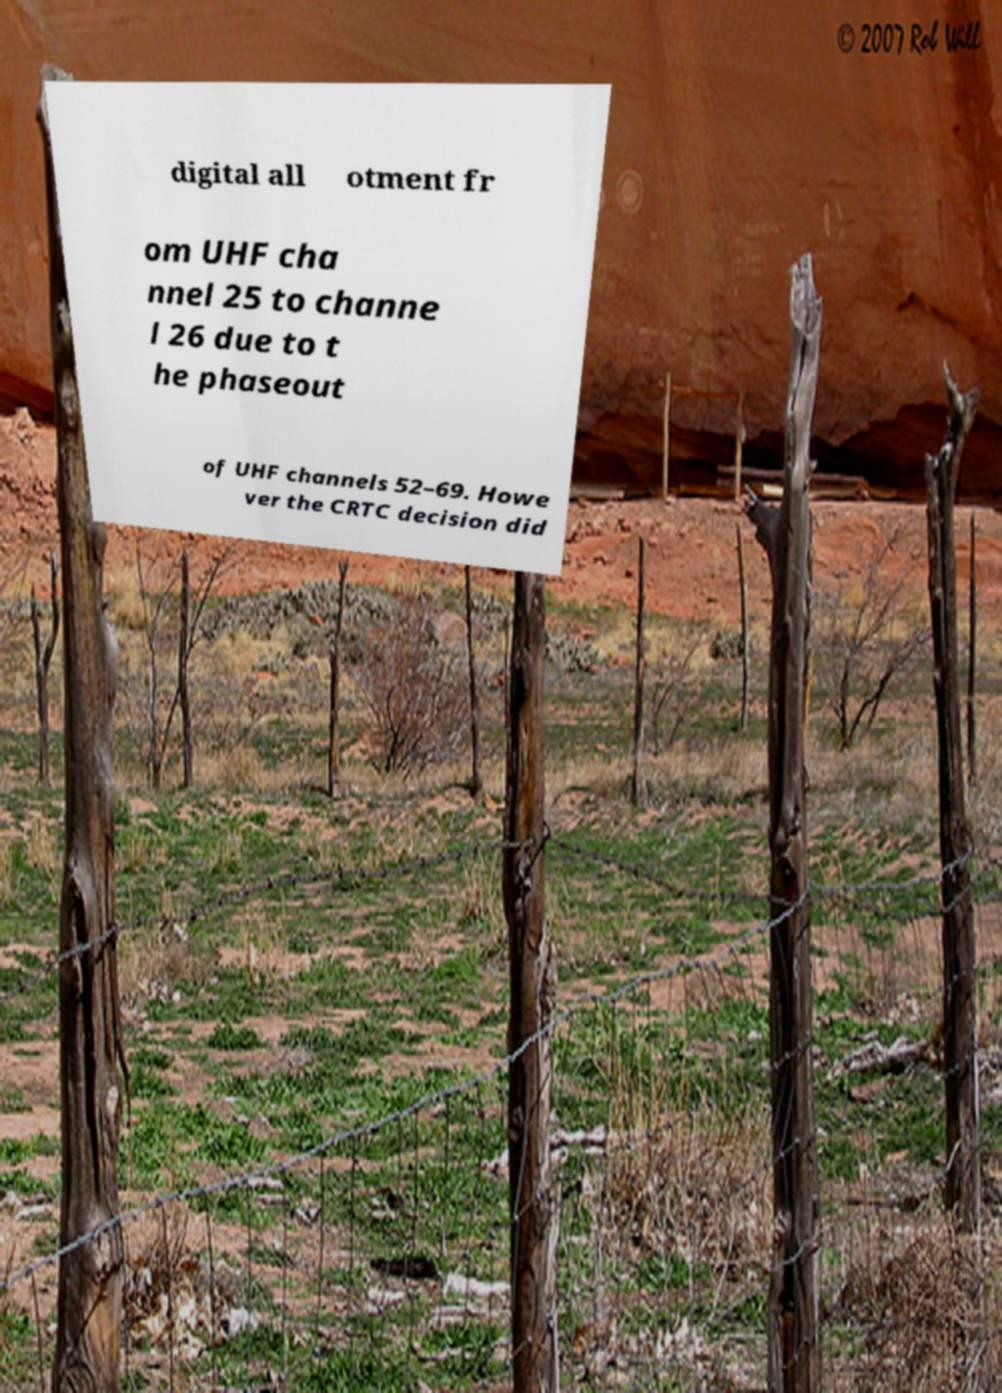Can you accurately transcribe the text from the provided image for me? digital all otment fr om UHF cha nnel 25 to channe l 26 due to t he phaseout of UHF channels 52–69. Howe ver the CRTC decision did 